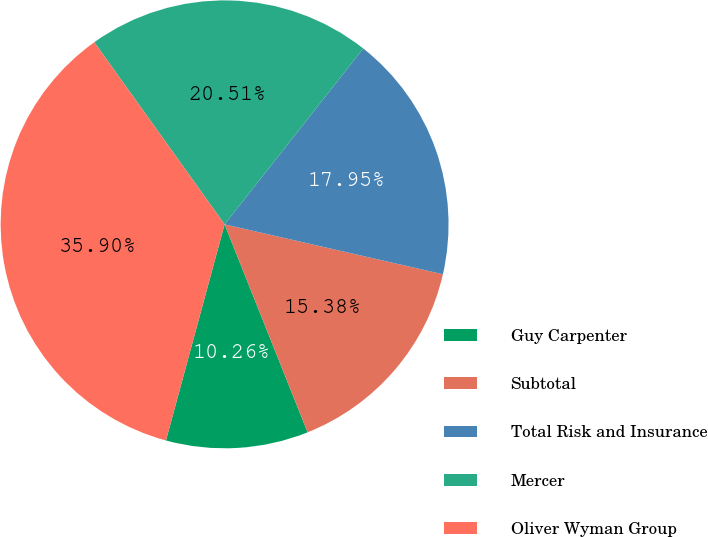Convert chart. <chart><loc_0><loc_0><loc_500><loc_500><pie_chart><fcel>Guy Carpenter<fcel>Subtotal<fcel>Total Risk and Insurance<fcel>Mercer<fcel>Oliver Wyman Group<nl><fcel>10.26%<fcel>15.38%<fcel>17.95%<fcel>20.51%<fcel>35.9%<nl></chart> 